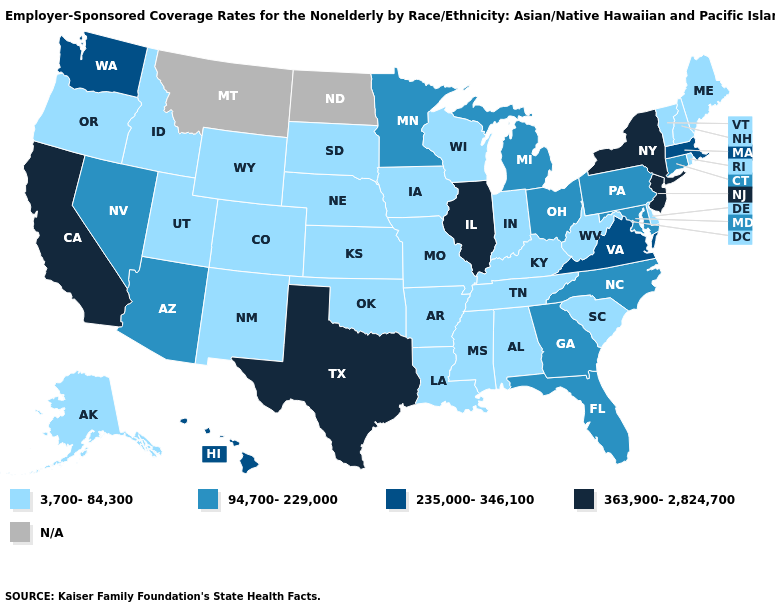Name the states that have a value in the range N/A?
Answer briefly. Montana, North Dakota. Which states have the lowest value in the Northeast?
Give a very brief answer. Maine, New Hampshire, Rhode Island, Vermont. Name the states that have a value in the range N/A?
Answer briefly. Montana, North Dakota. Name the states that have a value in the range 235,000-346,100?
Keep it brief. Hawaii, Massachusetts, Virginia, Washington. Does the map have missing data?
Short answer required. Yes. Which states hav the highest value in the MidWest?
Quick response, please. Illinois. Does Minnesota have the lowest value in the MidWest?
Concise answer only. No. What is the value of Louisiana?
Give a very brief answer. 3,700-84,300. Which states have the lowest value in the USA?
Keep it brief. Alabama, Alaska, Arkansas, Colorado, Delaware, Idaho, Indiana, Iowa, Kansas, Kentucky, Louisiana, Maine, Mississippi, Missouri, Nebraska, New Hampshire, New Mexico, Oklahoma, Oregon, Rhode Island, South Carolina, South Dakota, Tennessee, Utah, Vermont, West Virginia, Wisconsin, Wyoming. Name the states that have a value in the range 363,900-2,824,700?
Quick response, please. California, Illinois, New Jersey, New York, Texas. Name the states that have a value in the range N/A?
Keep it brief. Montana, North Dakota. Among the states that border New York , does Vermont have the lowest value?
Quick response, please. Yes. 